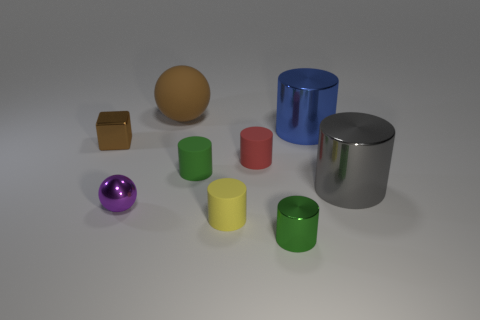What material is the thing that is the same color as the big ball?
Make the answer very short. Metal. Do the brown cube and the red rubber thing have the same size?
Your answer should be compact. Yes. What number of things are either metallic cylinders or large gray metallic cylinders?
Keep it short and to the point. 3. There is a green thing that is in front of the large cylinder that is in front of the green cylinder that is behind the small green metallic cylinder; what shape is it?
Your answer should be very brief. Cylinder. Does the tiny purple ball in front of the small cube have the same material as the brown thing on the right side of the tiny brown block?
Your answer should be compact. No. There is a red thing that is the same shape as the small yellow thing; what is its material?
Your answer should be compact. Rubber. There is a big gray metallic thing on the right side of the big blue cylinder; is its shape the same as the yellow object that is in front of the blue shiny cylinder?
Your response must be concise. Yes. Are there fewer small green objects left of the gray metal cylinder than tiny things behind the yellow matte cylinder?
Ensure brevity in your answer.  Yes. How many other things are there of the same shape as the purple object?
Your answer should be very brief. 1. There is a small brown object that is the same material as the purple sphere; what is its shape?
Give a very brief answer. Cube. 